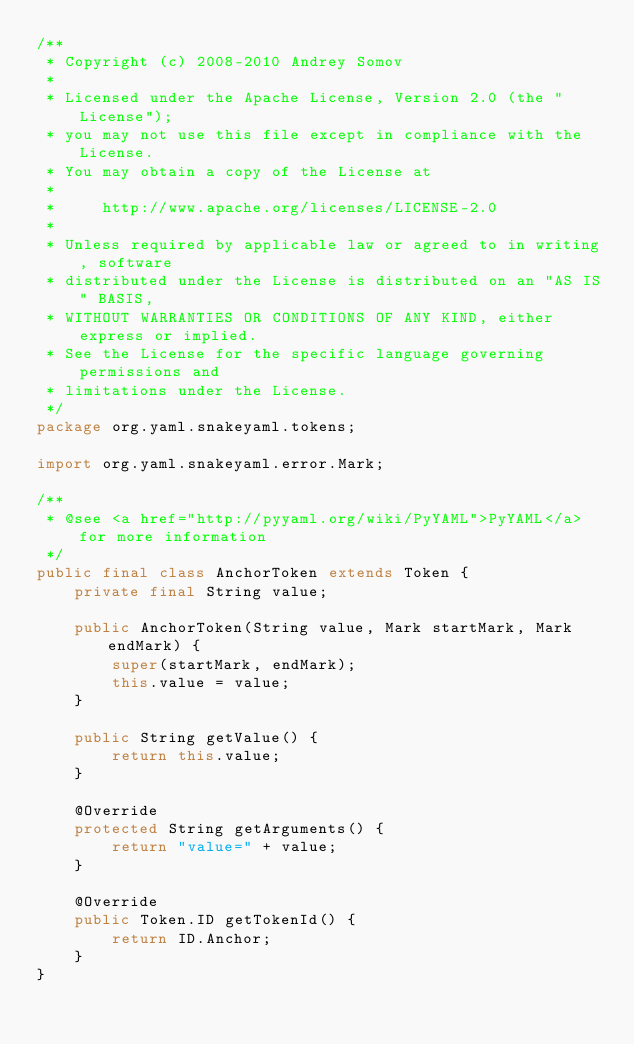Convert code to text. <code><loc_0><loc_0><loc_500><loc_500><_Java_>/**
 * Copyright (c) 2008-2010 Andrey Somov
 *
 * Licensed under the Apache License, Version 2.0 (the "License");
 * you may not use this file except in compliance with the License.
 * You may obtain a copy of the License at
 *
 *     http://www.apache.org/licenses/LICENSE-2.0
 *
 * Unless required by applicable law or agreed to in writing, software
 * distributed under the License is distributed on an "AS IS" BASIS,
 * WITHOUT WARRANTIES OR CONDITIONS OF ANY KIND, either express or implied.
 * See the License for the specific language governing permissions and
 * limitations under the License.
 */
package org.yaml.snakeyaml.tokens;

import org.yaml.snakeyaml.error.Mark;

/**
 * @see <a href="http://pyyaml.org/wiki/PyYAML">PyYAML</a> for more information
 */
public final class AnchorToken extends Token {
    private final String value;

    public AnchorToken(String value, Mark startMark, Mark endMark) {
        super(startMark, endMark);
        this.value = value;
    }

    public String getValue() {
        return this.value;
    }

    @Override
    protected String getArguments() {
        return "value=" + value;
    }

    @Override
    public Token.ID getTokenId() {
        return ID.Anchor;
    }
}
</code> 